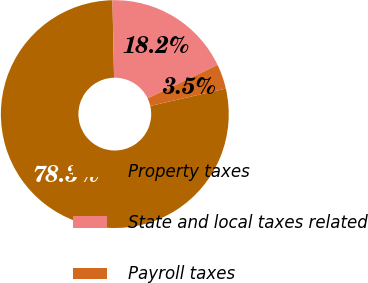Convert chart. <chart><loc_0><loc_0><loc_500><loc_500><pie_chart><fcel>Property taxes<fcel>State and local taxes related<fcel>Payroll taxes<nl><fcel>78.27%<fcel>18.23%<fcel>3.5%<nl></chart> 